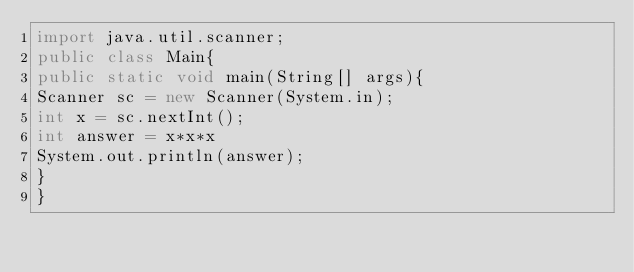Convert code to text. <code><loc_0><loc_0><loc_500><loc_500><_Java_>import java.util.scanner;
public class Main{
public static void main(String[] args){
Scanner sc = new Scanner(System.in);
int x = sc.nextInt();
int answer = x*x*x
System.out.println(answer); 
}
}</code> 